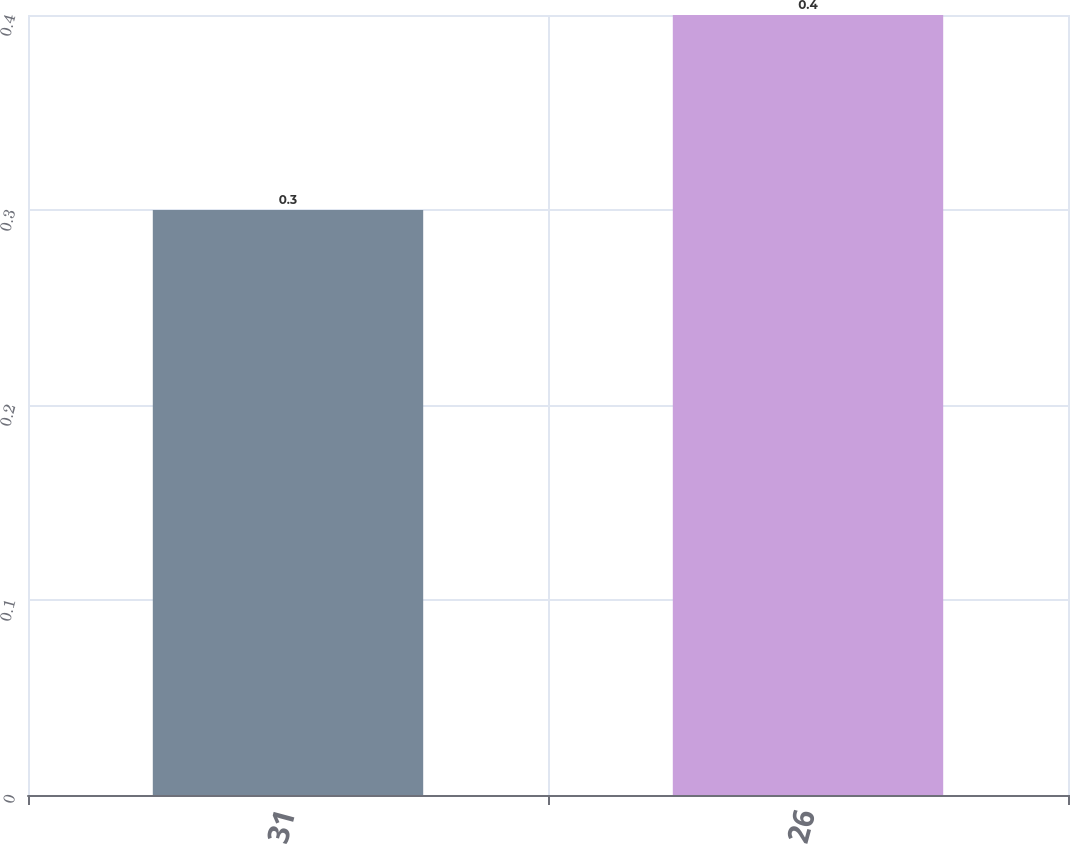Convert chart to OTSL. <chart><loc_0><loc_0><loc_500><loc_500><bar_chart><fcel>31<fcel>26<nl><fcel>0.3<fcel>0.4<nl></chart> 